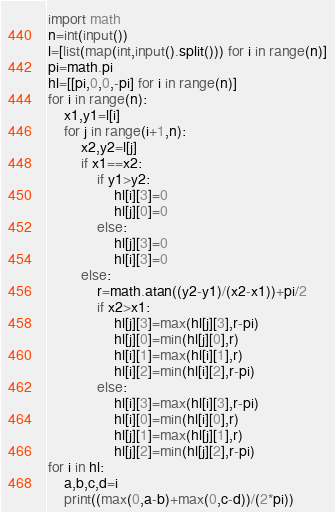<code> <loc_0><loc_0><loc_500><loc_500><_Python_>import math
n=int(input())
l=[list(map(int,input().split())) for i in range(n)]
pi=math.pi
hl=[[pi,0,0,-pi] for i in range(n)]
for i in range(n):
    x1,y1=l[i]
    for j in range(i+1,n):
        x2,y2=l[j]
        if x1==x2:
            if y1>y2:
                hl[i][3]=0
                hl[j][0]=0
            else:
                hl[j][3]=0
                hl[i][3]=0
        else:
            r=math.atan((y2-y1)/(x2-x1))+pi/2
            if x2>x1:
                hl[j][3]=max(hl[j][3],r-pi)
                hl[j][0]=min(hl[j][0],r)
                hl[i][1]=max(hl[i][1],r)
                hl[i][2]=min(hl[i][2],r-pi)
            else:
                hl[i][3]=max(hl[i][3],r-pi)
                hl[i][0]=min(hl[i][0],r)
                hl[j][1]=max(hl[j][1],r)
                hl[j][2]=min(hl[j][2],r-pi)
for i in hl:
    a,b,c,d=i
    print((max(0,a-b)+max(0,c-d))/(2*pi))</code> 